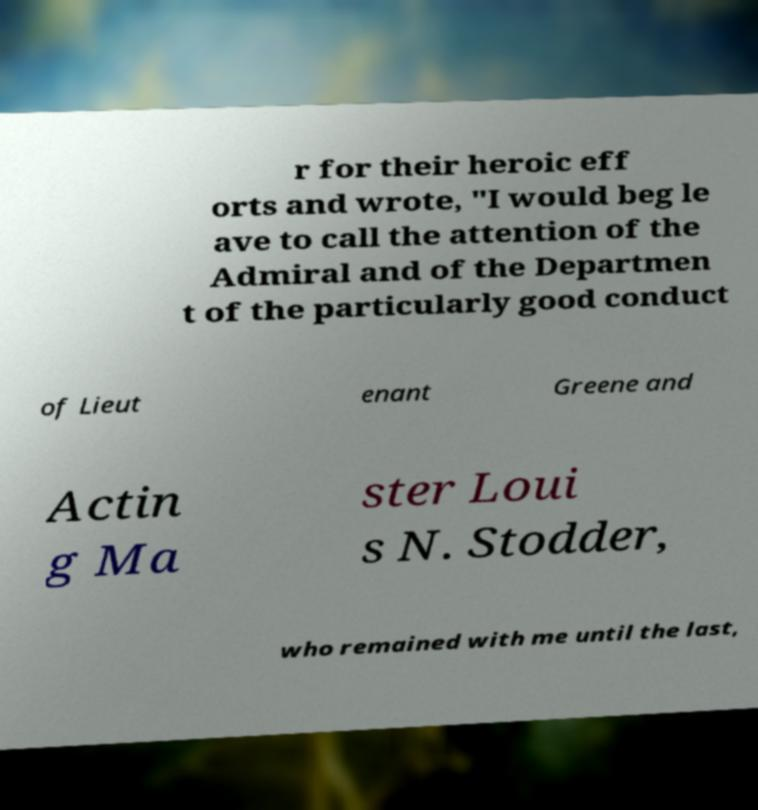Please read and relay the text visible in this image. What does it say? r for their heroic eff orts and wrote, "I would beg le ave to call the attention of the Admiral and of the Departmen t of the particularly good conduct of Lieut enant Greene and Actin g Ma ster Loui s N. Stodder, who remained with me until the last, 